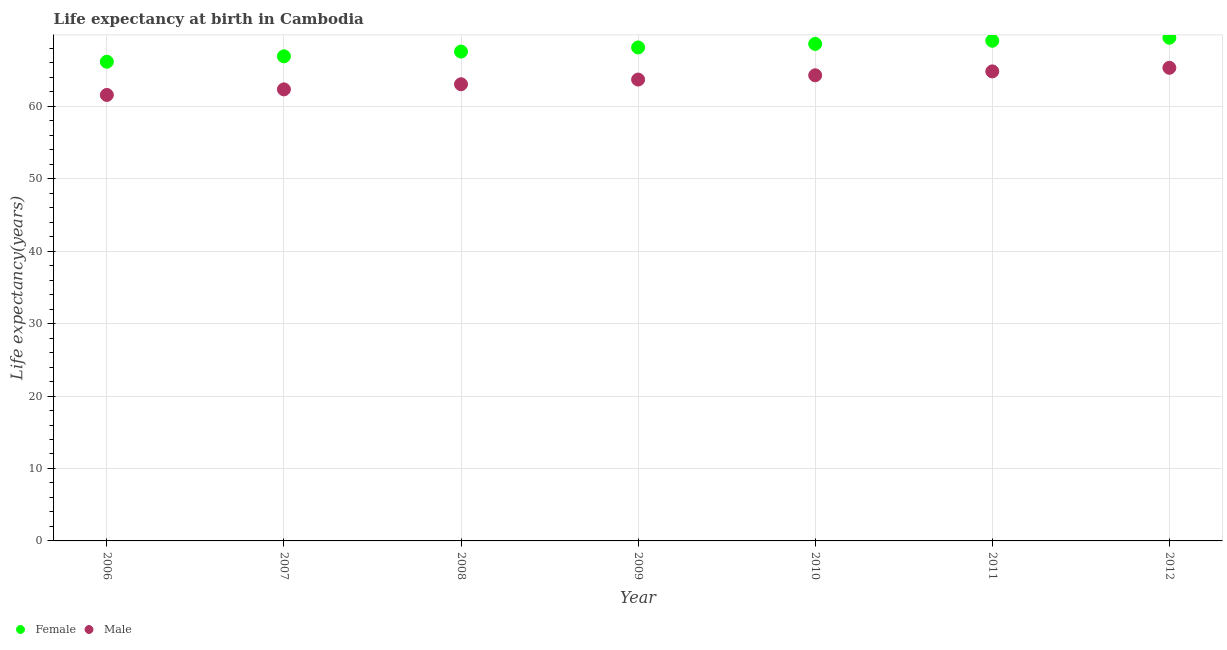Is the number of dotlines equal to the number of legend labels?
Ensure brevity in your answer.  Yes. What is the life expectancy(female) in 2011?
Keep it short and to the point. 69.04. Across all years, what is the maximum life expectancy(male)?
Ensure brevity in your answer.  65.3. Across all years, what is the minimum life expectancy(female)?
Give a very brief answer. 66.14. In which year was the life expectancy(male) minimum?
Your answer should be very brief. 2006. What is the total life expectancy(female) in the graph?
Provide a succinct answer. 475.79. What is the difference between the life expectancy(female) in 2008 and that in 2012?
Your answer should be very brief. -1.91. What is the difference between the life expectancy(male) in 2011 and the life expectancy(female) in 2010?
Provide a short and direct response. -3.8. What is the average life expectancy(male) per year?
Provide a short and direct response. 63.57. In the year 2008, what is the difference between the life expectancy(female) and life expectancy(male)?
Offer a terse response. 4.51. What is the ratio of the life expectancy(female) in 2006 to that in 2011?
Provide a succinct answer. 0.96. Is the life expectancy(female) in 2007 less than that in 2009?
Give a very brief answer. Yes. Is the difference between the life expectancy(female) in 2009 and 2011 greater than the difference between the life expectancy(male) in 2009 and 2011?
Your answer should be very brief. Yes. What is the difference between the highest and the second highest life expectancy(male)?
Make the answer very short. 0.5. What is the difference between the highest and the lowest life expectancy(female)?
Your answer should be very brief. 3.31. Does the life expectancy(male) monotonically increase over the years?
Offer a terse response. Yes. What is the difference between two consecutive major ticks on the Y-axis?
Your response must be concise. 10. Does the graph contain any zero values?
Offer a terse response. No. Does the graph contain grids?
Make the answer very short. Yes. How are the legend labels stacked?
Your answer should be very brief. Horizontal. What is the title of the graph?
Your answer should be very brief. Life expectancy at birth in Cambodia. What is the label or title of the Y-axis?
Your answer should be very brief. Life expectancy(years). What is the Life expectancy(years) in Female in 2006?
Offer a terse response. 66.14. What is the Life expectancy(years) in Male in 2006?
Ensure brevity in your answer.  61.56. What is the Life expectancy(years) of Female in 2007?
Give a very brief answer. 66.89. What is the Life expectancy(years) of Male in 2007?
Your response must be concise. 62.33. What is the Life expectancy(years) in Female in 2008?
Offer a very short reply. 67.55. What is the Life expectancy(years) in Male in 2008?
Make the answer very short. 63.03. What is the Life expectancy(years) in Female in 2009?
Ensure brevity in your answer.  68.11. What is the Life expectancy(years) of Male in 2009?
Your answer should be compact. 63.68. What is the Life expectancy(years) in Female in 2010?
Ensure brevity in your answer.  68.61. What is the Life expectancy(years) of Male in 2010?
Your response must be concise. 64.27. What is the Life expectancy(years) of Female in 2011?
Give a very brief answer. 69.04. What is the Life expectancy(years) in Male in 2011?
Your answer should be very brief. 64.81. What is the Life expectancy(years) of Female in 2012?
Give a very brief answer. 69.45. What is the Life expectancy(years) of Male in 2012?
Your answer should be compact. 65.3. Across all years, what is the maximum Life expectancy(years) of Female?
Give a very brief answer. 69.45. Across all years, what is the maximum Life expectancy(years) of Male?
Your answer should be compact. 65.3. Across all years, what is the minimum Life expectancy(years) of Female?
Offer a very short reply. 66.14. Across all years, what is the minimum Life expectancy(years) in Male?
Your answer should be compact. 61.56. What is the total Life expectancy(years) of Female in the graph?
Keep it short and to the point. 475.8. What is the total Life expectancy(years) in Male in the graph?
Ensure brevity in your answer.  444.99. What is the difference between the Life expectancy(years) in Female in 2006 and that in 2007?
Your answer should be compact. -0.75. What is the difference between the Life expectancy(years) of Male in 2006 and that in 2007?
Your answer should be very brief. -0.77. What is the difference between the Life expectancy(years) of Female in 2006 and that in 2008?
Provide a succinct answer. -1.4. What is the difference between the Life expectancy(years) of Male in 2006 and that in 2008?
Make the answer very short. -1.48. What is the difference between the Life expectancy(years) of Female in 2006 and that in 2009?
Provide a short and direct response. -1.97. What is the difference between the Life expectancy(years) in Male in 2006 and that in 2009?
Your answer should be compact. -2.12. What is the difference between the Life expectancy(years) in Female in 2006 and that in 2010?
Your answer should be compact. -2.46. What is the difference between the Life expectancy(years) in Male in 2006 and that in 2010?
Your answer should be compact. -2.71. What is the difference between the Life expectancy(years) in Female in 2006 and that in 2011?
Make the answer very short. -2.9. What is the difference between the Life expectancy(years) in Male in 2006 and that in 2011?
Keep it short and to the point. -3.25. What is the difference between the Life expectancy(years) of Female in 2006 and that in 2012?
Keep it short and to the point. -3.31. What is the difference between the Life expectancy(years) of Male in 2006 and that in 2012?
Offer a terse response. -3.75. What is the difference between the Life expectancy(years) in Female in 2007 and that in 2008?
Your answer should be compact. -0.66. What is the difference between the Life expectancy(years) of Male in 2007 and that in 2008?
Your answer should be very brief. -0.71. What is the difference between the Life expectancy(years) of Female in 2007 and that in 2009?
Your answer should be very brief. -1.22. What is the difference between the Life expectancy(years) of Male in 2007 and that in 2009?
Provide a short and direct response. -1.36. What is the difference between the Life expectancy(years) in Female in 2007 and that in 2010?
Offer a terse response. -1.72. What is the difference between the Life expectancy(years) in Male in 2007 and that in 2010?
Provide a succinct answer. -1.95. What is the difference between the Life expectancy(years) in Female in 2007 and that in 2011?
Your response must be concise. -2.15. What is the difference between the Life expectancy(years) of Male in 2007 and that in 2011?
Ensure brevity in your answer.  -2.48. What is the difference between the Life expectancy(years) of Female in 2007 and that in 2012?
Give a very brief answer. -2.56. What is the difference between the Life expectancy(years) in Male in 2007 and that in 2012?
Your answer should be very brief. -2.98. What is the difference between the Life expectancy(years) of Female in 2008 and that in 2009?
Provide a succinct answer. -0.57. What is the difference between the Life expectancy(years) in Male in 2008 and that in 2009?
Provide a short and direct response. -0.65. What is the difference between the Life expectancy(years) of Female in 2008 and that in 2010?
Your response must be concise. -1.06. What is the difference between the Life expectancy(years) of Male in 2008 and that in 2010?
Offer a very short reply. -1.24. What is the difference between the Life expectancy(years) in Female in 2008 and that in 2011?
Your answer should be very brief. -1.5. What is the difference between the Life expectancy(years) of Male in 2008 and that in 2011?
Provide a succinct answer. -1.77. What is the difference between the Life expectancy(years) in Female in 2008 and that in 2012?
Provide a succinct answer. -1.91. What is the difference between the Life expectancy(years) in Male in 2008 and that in 2012?
Provide a succinct answer. -2.27. What is the difference between the Life expectancy(years) of Female in 2009 and that in 2010?
Your answer should be compact. -0.49. What is the difference between the Life expectancy(years) in Male in 2009 and that in 2010?
Offer a terse response. -0.59. What is the difference between the Life expectancy(years) of Female in 2009 and that in 2011?
Your response must be concise. -0.93. What is the difference between the Life expectancy(years) in Male in 2009 and that in 2011?
Provide a succinct answer. -1.12. What is the difference between the Life expectancy(years) in Female in 2009 and that in 2012?
Make the answer very short. -1.34. What is the difference between the Life expectancy(years) of Male in 2009 and that in 2012?
Offer a terse response. -1.62. What is the difference between the Life expectancy(years) in Female in 2010 and that in 2011?
Your answer should be very brief. -0.44. What is the difference between the Life expectancy(years) in Male in 2010 and that in 2011?
Your response must be concise. -0.54. What is the difference between the Life expectancy(years) in Female in 2010 and that in 2012?
Keep it short and to the point. -0.85. What is the difference between the Life expectancy(years) in Male in 2010 and that in 2012?
Keep it short and to the point. -1.03. What is the difference between the Life expectancy(years) of Female in 2011 and that in 2012?
Give a very brief answer. -0.41. What is the difference between the Life expectancy(years) in Male in 2011 and that in 2012?
Give a very brief answer. -0.5. What is the difference between the Life expectancy(years) in Female in 2006 and the Life expectancy(years) in Male in 2007?
Your answer should be very brief. 3.82. What is the difference between the Life expectancy(years) in Female in 2006 and the Life expectancy(years) in Male in 2008?
Make the answer very short. 3.11. What is the difference between the Life expectancy(years) in Female in 2006 and the Life expectancy(years) in Male in 2009?
Offer a very short reply. 2.46. What is the difference between the Life expectancy(years) of Female in 2006 and the Life expectancy(years) of Male in 2010?
Your answer should be compact. 1.87. What is the difference between the Life expectancy(years) in Female in 2006 and the Life expectancy(years) in Male in 2011?
Keep it short and to the point. 1.34. What is the difference between the Life expectancy(years) in Female in 2006 and the Life expectancy(years) in Male in 2012?
Offer a terse response. 0.84. What is the difference between the Life expectancy(years) of Female in 2007 and the Life expectancy(years) of Male in 2008?
Offer a terse response. 3.86. What is the difference between the Life expectancy(years) in Female in 2007 and the Life expectancy(years) in Male in 2009?
Ensure brevity in your answer.  3.21. What is the difference between the Life expectancy(years) in Female in 2007 and the Life expectancy(years) in Male in 2010?
Make the answer very short. 2.62. What is the difference between the Life expectancy(years) of Female in 2007 and the Life expectancy(years) of Male in 2011?
Make the answer very short. 2.08. What is the difference between the Life expectancy(years) of Female in 2007 and the Life expectancy(years) of Male in 2012?
Give a very brief answer. 1.59. What is the difference between the Life expectancy(years) of Female in 2008 and the Life expectancy(years) of Male in 2009?
Keep it short and to the point. 3.86. What is the difference between the Life expectancy(years) in Female in 2008 and the Life expectancy(years) in Male in 2010?
Provide a short and direct response. 3.27. What is the difference between the Life expectancy(years) of Female in 2008 and the Life expectancy(years) of Male in 2011?
Your answer should be compact. 2.74. What is the difference between the Life expectancy(years) of Female in 2008 and the Life expectancy(years) of Male in 2012?
Offer a terse response. 2.24. What is the difference between the Life expectancy(years) in Female in 2009 and the Life expectancy(years) in Male in 2010?
Make the answer very short. 3.84. What is the difference between the Life expectancy(years) in Female in 2009 and the Life expectancy(years) in Male in 2011?
Offer a terse response. 3.31. What is the difference between the Life expectancy(years) in Female in 2009 and the Life expectancy(years) in Male in 2012?
Ensure brevity in your answer.  2.81. What is the difference between the Life expectancy(years) in Female in 2010 and the Life expectancy(years) in Male in 2011?
Offer a very short reply. 3.8. What is the difference between the Life expectancy(years) in Female in 2010 and the Life expectancy(years) in Male in 2012?
Make the answer very short. 3.3. What is the difference between the Life expectancy(years) in Female in 2011 and the Life expectancy(years) in Male in 2012?
Offer a very short reply. 3.74. What is the average Life expectancy(years) of Female per year?
Make the answer very short. 67.97. What is the average Life expectancy(years) of Male per year?
Provide a succinct answer. 63.57. In the year 2006, what is the difference between the Life expectancy(years) of Female and Life expectancy(years) of Male?
Your response must be concise. 4.58. In the year 2007, what is the difference between the Life expectancy(years) in Female and Life expectancy(years) in Male?
Ensure brevity in your answer.  4.56. In the year 2008, what is the difference between the Life expectancy(years) in Female and Life expectancy(years) in Male?
Offer a terse response. 4.51. In the year 2009, what is the difference between the Life expectancy(years) in Female and Life expectancy(years) in Male?
Make the answer very short. 4.43. In the year 2010, what is the difference between the Life expectancy(years) in Female and Life expectancy(years) in Male?
Offer a terse response. 4.33. In the year 2011, what is the difference between the Life expectancy(years) of Female and Life expectancy(years) of Male?
Keep it short and to the point. 4.23. In the year 2012, what is the difference between the Life expectancy(years) of Female and Life expectancy(years) of Male?
Ensure brevity in your answer.  4.15. What is the ratio of the Life expectancy(years) in Female in 2006 to that in 2008?
Make the answer very short. 0.98. What is the ratio of the Life expectancy(years) in Male in 2006 to that in 2008?
Keep it short and to the point. 0.98. What is the ratio of the Life expectancy(years) in Female in 2006 to that in 2009?
Your answer should be very brief. 0.97. What is the ratio of the Life expectancy(years) of Male in 2006 to that in 2009?
Offer a terse response. 0.97. What is the ratio of the Life expectancy(years) of Female in 2006 to that in 2010?
Your answer should be very brief. 0.96. What is the ratio of the Life expectancy(years) in Male in 2006 to that in 2010?
Your answer should be very brief. 0.96. What is the ratio of the Life expectancy(years) of Female in 2006 to that in 2011?
Provide a short and direct response. 0.96. What is the ratio of the Life expectancy(years) of Male in 2006 to that in 2011?
Your answer should be compact. 0.95. What is the ratio of the Life expectancy(years) in Female in 2006 to that in 2012?
Your answer should be very brief. 0.95. What is the ratio of the Life expectancy(years) of Male in 2006 to that in 2012?
Your answer should be compact. 0.94. What is the ratio of the Life expectancy(years) in Female in 2007 to that in 2008?
Provide a succinct answer. 0.99. What is the ratio of the Life expectancy(years) in Male in 2007 to that in 2008?
Offer a very short reply. 0.99. What is the ratio of the Life expectancy(years) in Female in 2007 to that in 2009?
Provide a succinct answer. 0.98. What is the ratio of the Life expectancy(years) in Male in 2007 to that in 2009?
Make the answer very short. 0.98. What is the ratio of the Life expectancy(years) in Male in 2007 to that in 2010?
Provide a short and direct response. 0.97. What is the ratio of the Life expectancy(years) in Female in 2007 to that in 2011?
Make the answer very short. 0.97. What is the ratio of the Life expectancy(years) in Male in 2007 to that in 2011?
Your answer should be very brief. 0.96. What is the ratio of the Life expectancy(years) in Female in 2007 to that in 2012?
Ensure brevity in your answer.  0.96. What is the ratio of the Life expectancy(years) of Male in 2007 to that in 2012?
Ensure brevity in your answer.  0.95. What is the ratio of the Life expectancy(years) of Female in 2008 to that in 2010?
Provide a short and direct response. 0.98. What is the ratio of the Life expectancy(years) of Male in 2008 to that in 2010?
Your answer should be compact. 0.98. What is the ratio of the Life expectancy(years) in Female in 2008 to that in 2011?
Your response must be concise. 0.98. What is the ratio of the Life expectancy(years) of Male in 2008 to that in 2011?
Give a very brief answer. 0.97. What is the ratio of the Life expectancy(years) of Female in 2008 to that in 2012?
Ensure brevity in your answer.  0.97. What is the ratio of the Life expectancy(years) in Male in 2008 to that in 2012?
Provide a short and direct response. 0.97. What is the ratio of the Life expectancy(years) of Male in 2009 to that in 2010?
Make the answer very short. 0.99. What is the ratio of the Life expectancy(years) of Female in 2009 to that in 2011?
Make the answer very short. 0.99. What is the ratio of the Life expectancy(years) in Male in 2009 to that in 2011?
Your response must be concise. 0.98. What is the ratio of the Life expectancy(years) in Female in 2009 to that in 2012?
Provide a short and direct response. 0.98. What is the ratio of the Life expectancy(years) in Male in 2009 to that in 2012?
Provide a succinct answer. 0.98. What is the ratio of the Life expectancy(years) of Female in 2010 to that in 2012?
Your answer should be very brief. 0.99. What is the ratio of the Life expectancy(years) of Male in 2010 to that in 2012?
Your answer should be compact. 0.98. What is the ratio of the Life expectancy(years) in Male in 2011 to that in 2012?
Ensure brevity in your answer.  0.99. What is the difference between the highest and the second highest Life expectancy(years) of Female?
Keep it short and to the point. 0.41. What is the difference between the highest and the second highest Life expectancy(years) of Male?
Your response must be concise. 0.5. What is the difference between the highest and the lowest Life expectancy(years) of Female?
Your answer should be compact. 3.31. What is the difference between the highest and the lowest Life expectancy(years) of Male?
Provide a succinct answer. 3.75. 